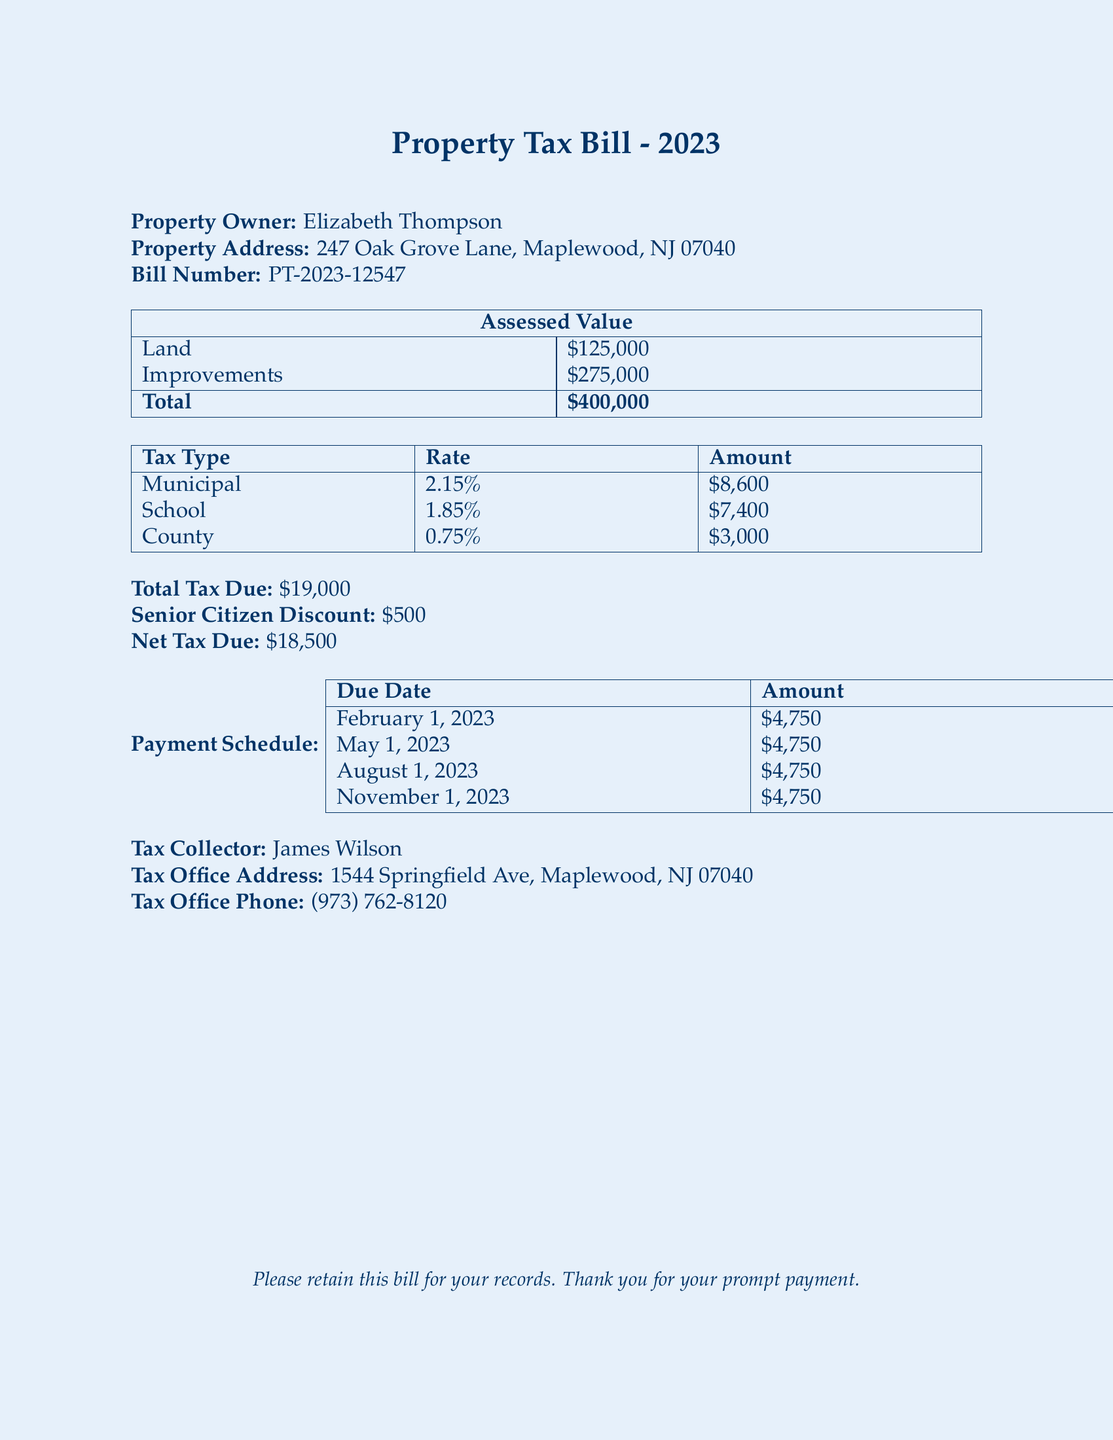What is the property owner's name? The property owner's name is located near the top of the document.
Answer: Elizabeth Thompson What is the total assessed value of the property? The total assessed value is indicated in the table summarizing land and improvements.
Answer: $400,000 What is the municipal tax rate? The municipal tax rate can be found in the tax breakdown table.
Answer: 2.15% How much is the senior citizen discount? The senior citizen discount is listed in the summary of deductions in the document.
Answer: $500 When is the final payment due? The final payment date is part of the payment schedule in the document.
Answer: November 1, 2023 What is the total tax due before deductions? The total tax due before any discounts is stated in the summary section.
Answer: $19,000 What amount is due on August 1, 2023? The payment schedule outlines the amounts due on specific dates.
Answer: $4,750 How much does the school tax contribute to the total tax? The contribution from the school tax is detailed in the tax breakdown.
Answer: $7,400 Who is the tax collector? The name of the tax collector is specified at the bottom of the document.
Answer: James Wilson 